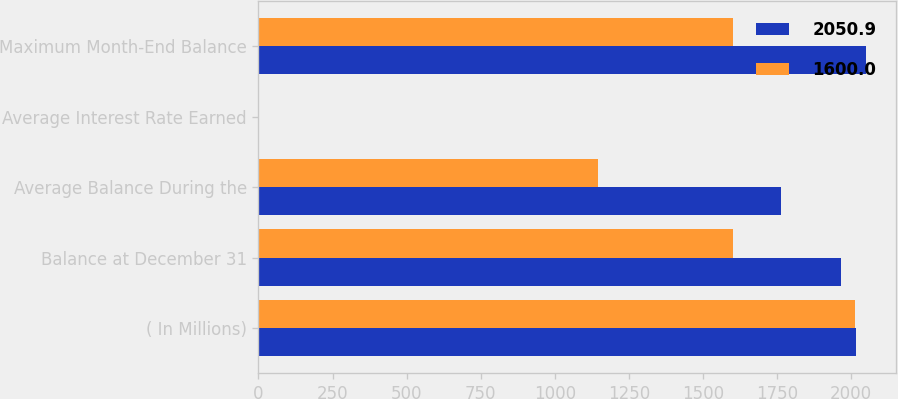<chart> <loc_0><loc_0><loc_500><loc_500><stacked_bar_chart><ecel><fcel>( In Millions)<fcel>Balance at December 31<fcel>Average Balance During the<fcel>Average Interest Rate Earned<fcel>Maximum Month-End Balance<nl><fcel>2050.9<fcel>2016<fcel>1967.5<fcel>1764.1<fcel>1.04<fcel>2050.9<nl><fcel>1600<fcel>2015<fcel>1600<fcel>1144.7<fcel>0.54<fcel>1600<nl></chart> 